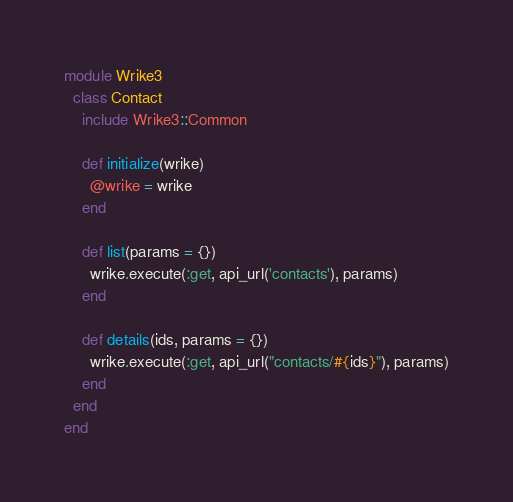Convert code to text. <code><loc_0><loc_0><loc_500><loc_500><_Ruby_>module Wrike3
  class Contact
    include Wrike3::Common

    def initialize(wrike)
      @wrike = wrike
    end

    def list(params = {})
      wrike.execute(:get, api_url('contacts'), params)
    end

    def details(ids, params = {})
      wrike.execute(:get, api_url("contacts/#{ids}"), params)
    end
  end
end
</code> 